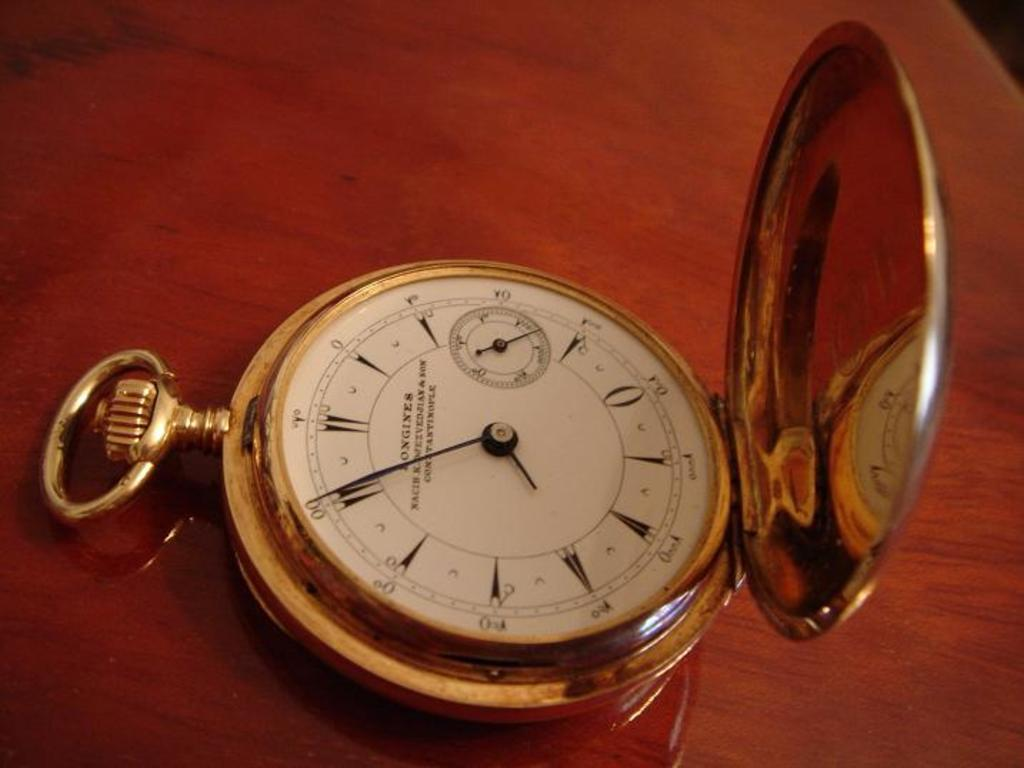<image>
Write a terse but informative summary of the picture. A pocket watch has many symbols on it including one that looks like a zero. 